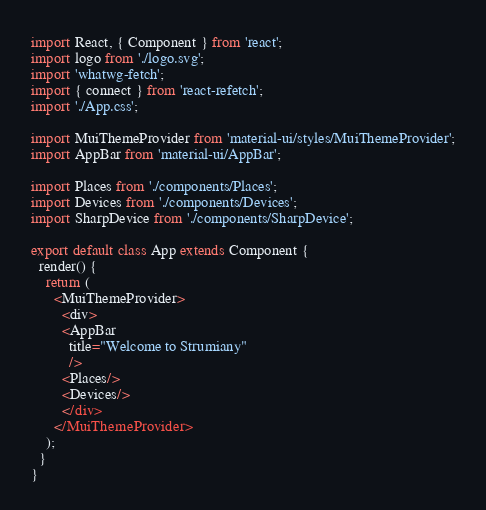Convert code to text. <code><loc_0><loc_0><loc_500><loc_500><_JavaScript_>import React, { Component } from 'react';
import logo from './logo.svg';
import 'whatwg-fetch';
import { connect } from 'react-refetch';
import './App.css';

import MuiThemeProvider from 'material-ui/styles/MuiThemeProvider';
import AppBar from 'material-ui/AppBar';

import Places from './components/Places';
import Devices from './components/Devices';
import SharpDevice from './components/SharpDevice';

export default class App extends Component {
  render() {
    return (
      <MuiThemeProvider>
        <div>
        <AppBar
          title="Welcome to Strumiany"
          />
        <Places/>
        <Devices/>
        </div>
      </MuiThemeProvider>
    );
  }
}
</code> 